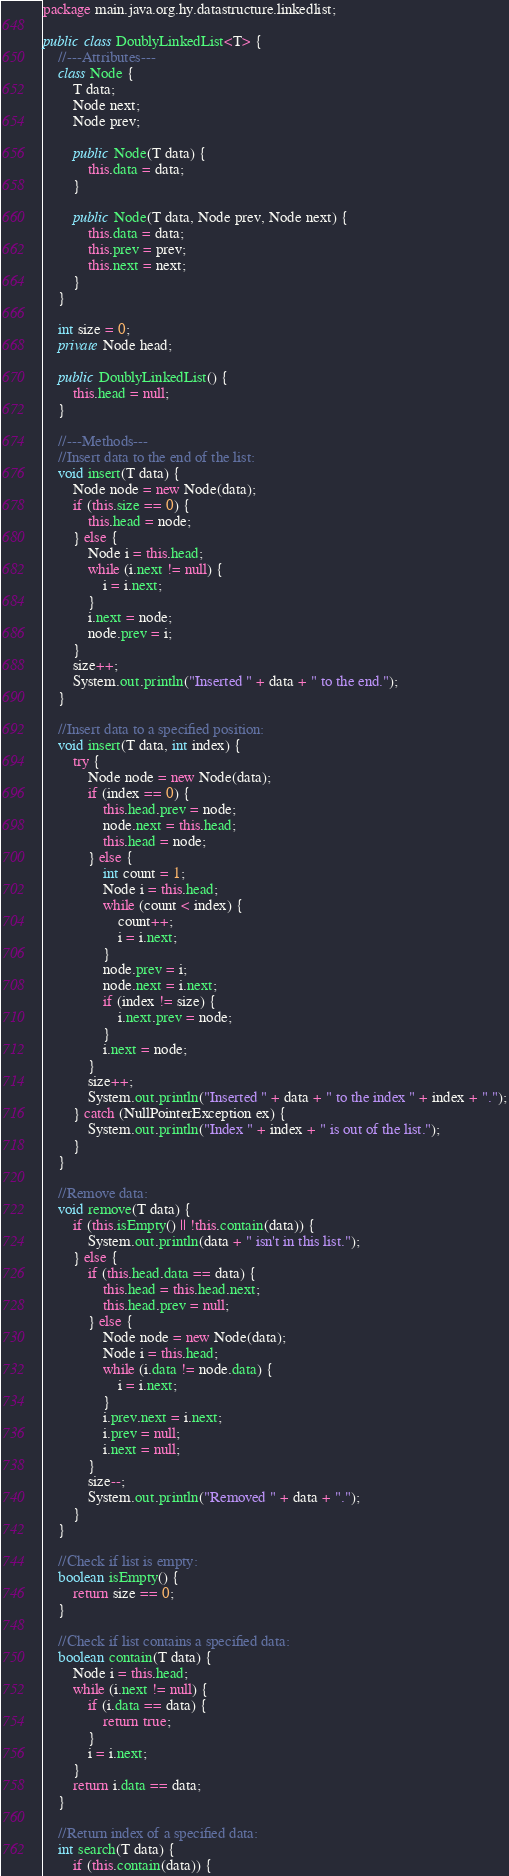Convert code to text. <code><loc_0><loc_0><loc_500><loc_500><_Java_>package main.java.org.hy.datastructure.linkedlist;

public class DoublyLinkedList<T> {
    //---Attributes---
    class Node {
        T data;
        Node next;
        Node prev;

        public Node(T data) {
            this.data = data;
        }

        public Node(T data, Node prev, Node next) {
            this.data = data;
            this.prev = prev;
            this.next = next;
        }
    }

    int size = 0;
    private Node head;

    public DoublyLinkedList() {
        this.head = null;
    }

    //---Methods---
    //Insert data to the end of the list:
    void insert(T data) {
        Node node = new Node(data);
        if (this.size == 0) {
            this.head = node;
        } else {
            Node i = this.head;
            while (i.next != null) {
                i = i.next;
            }
            i.next = node;
            node.prev = i;
        }
        size++;
        System.out.println("Inserted " + data + " to the end.");
    }

    //Insert data to a specified position:
    void insert(T data, int index) {
        try {
            Node node = new Node(data);
            if (index == 0) {
                this.head.prev = node;
                node.next = this.head;
                this.head = node;
            } else {
                int count = 1;
                Node i = this.head;
                while (count < index) {
                    count++;
                    i = i.next;
                }
                node.prev = i;
                node.next = i.next;
                if (index != size) {
                    i.next.prev = node;
                }
                i.next = node;
            }
            size++;
            System.out.println("Inserted " + data + " to the index " + index + ".");
        } catch (NullPointerException ex) {
            System.out.println("Index " + index + " is out of the list.");
        }
    }

    //Remove data:
    void remove(T data) {
        if (this.isEmpty() || !this.contain(data)) {
            System.out.println(data + " isn't in this list.");
        } else {
            if (this.head.data == data) {
                this.head = this.head.next;
                this.head.prev = null;
            } else {
                Node node = new Node(data);
                Node i = this.head;
                while (i.data != node.data) {
                    i = i.next;
                }
                i.prev.next = i.next;
                i.prev = null;
                i.next = null;
            }
            size--;
            System.out.println("Removed " + data + ".");
        }
    }

    //Check if list is empty:
    boolean isEmpty() {
        return size == 0;
    }

    //Check if list contains a specified data:
    boolean contain(T data) {
        Node i = this.head;
        while (i.next != null) {
            if (i.data == data) {
                return true;
            }
            i = i.next;
        }
        return i.data == data;
    }

    //Return index of a specified data:
    int search(T data) {
        if (this.contain(data)) {</code> 